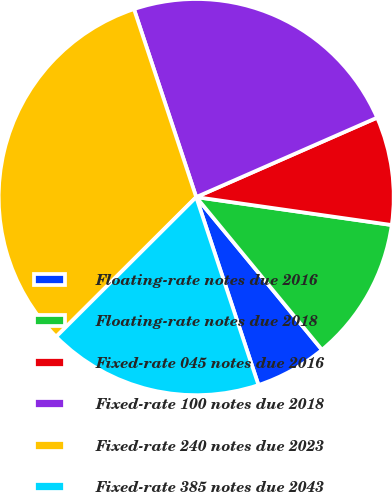Convert chart. <chart><loc_0><loc_0><loc_500><loc_500><pie_chart><fcel>Floating-rate notes due 2016<fcel>Floating-rate notes due 2018<fcel>Fixed-rate 045 notes due 2016<fcel>Fixed-rate 100 notes due 2018<fcel>Fixed-rate 240 notes due 2023<fcel>Fixed-rate 385 notes due 2043<nl><fcel>5.88%<fcel>11.76%<fcel>8.82%<fcel>23.53%<fcel>32.35%<fcel>17.65%<nl></chart> 